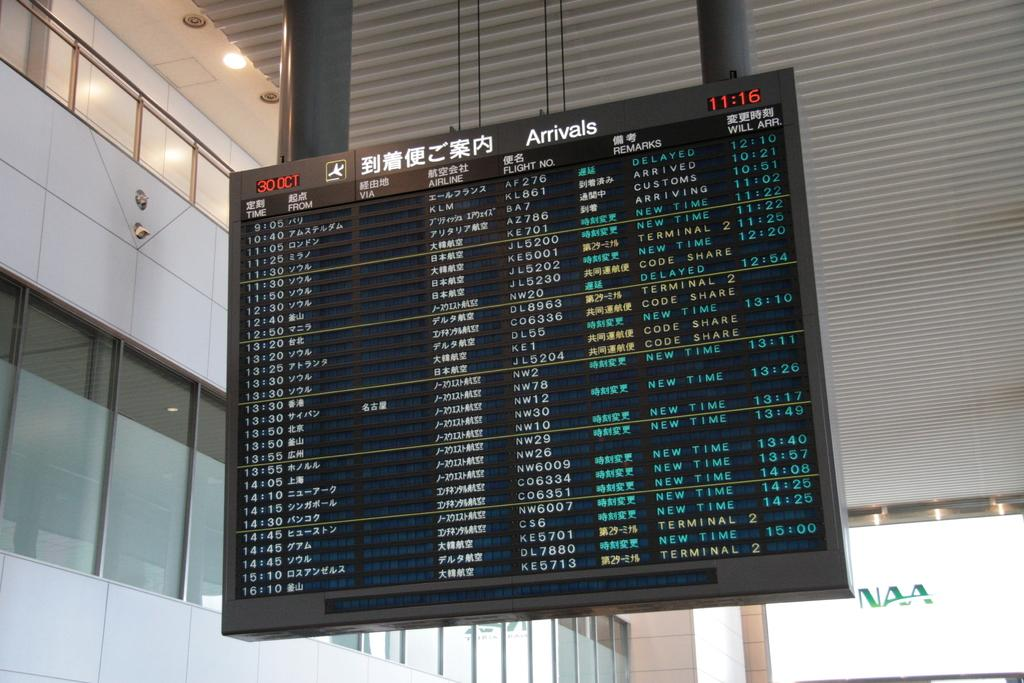What is the main object in the center of the image? There is a display board in the center of the image. What can be seen in the background of the image? There is a building in the background of the image. What type of pancake is being served on the display board in the image? There is no pancake present on the display board in the image. 